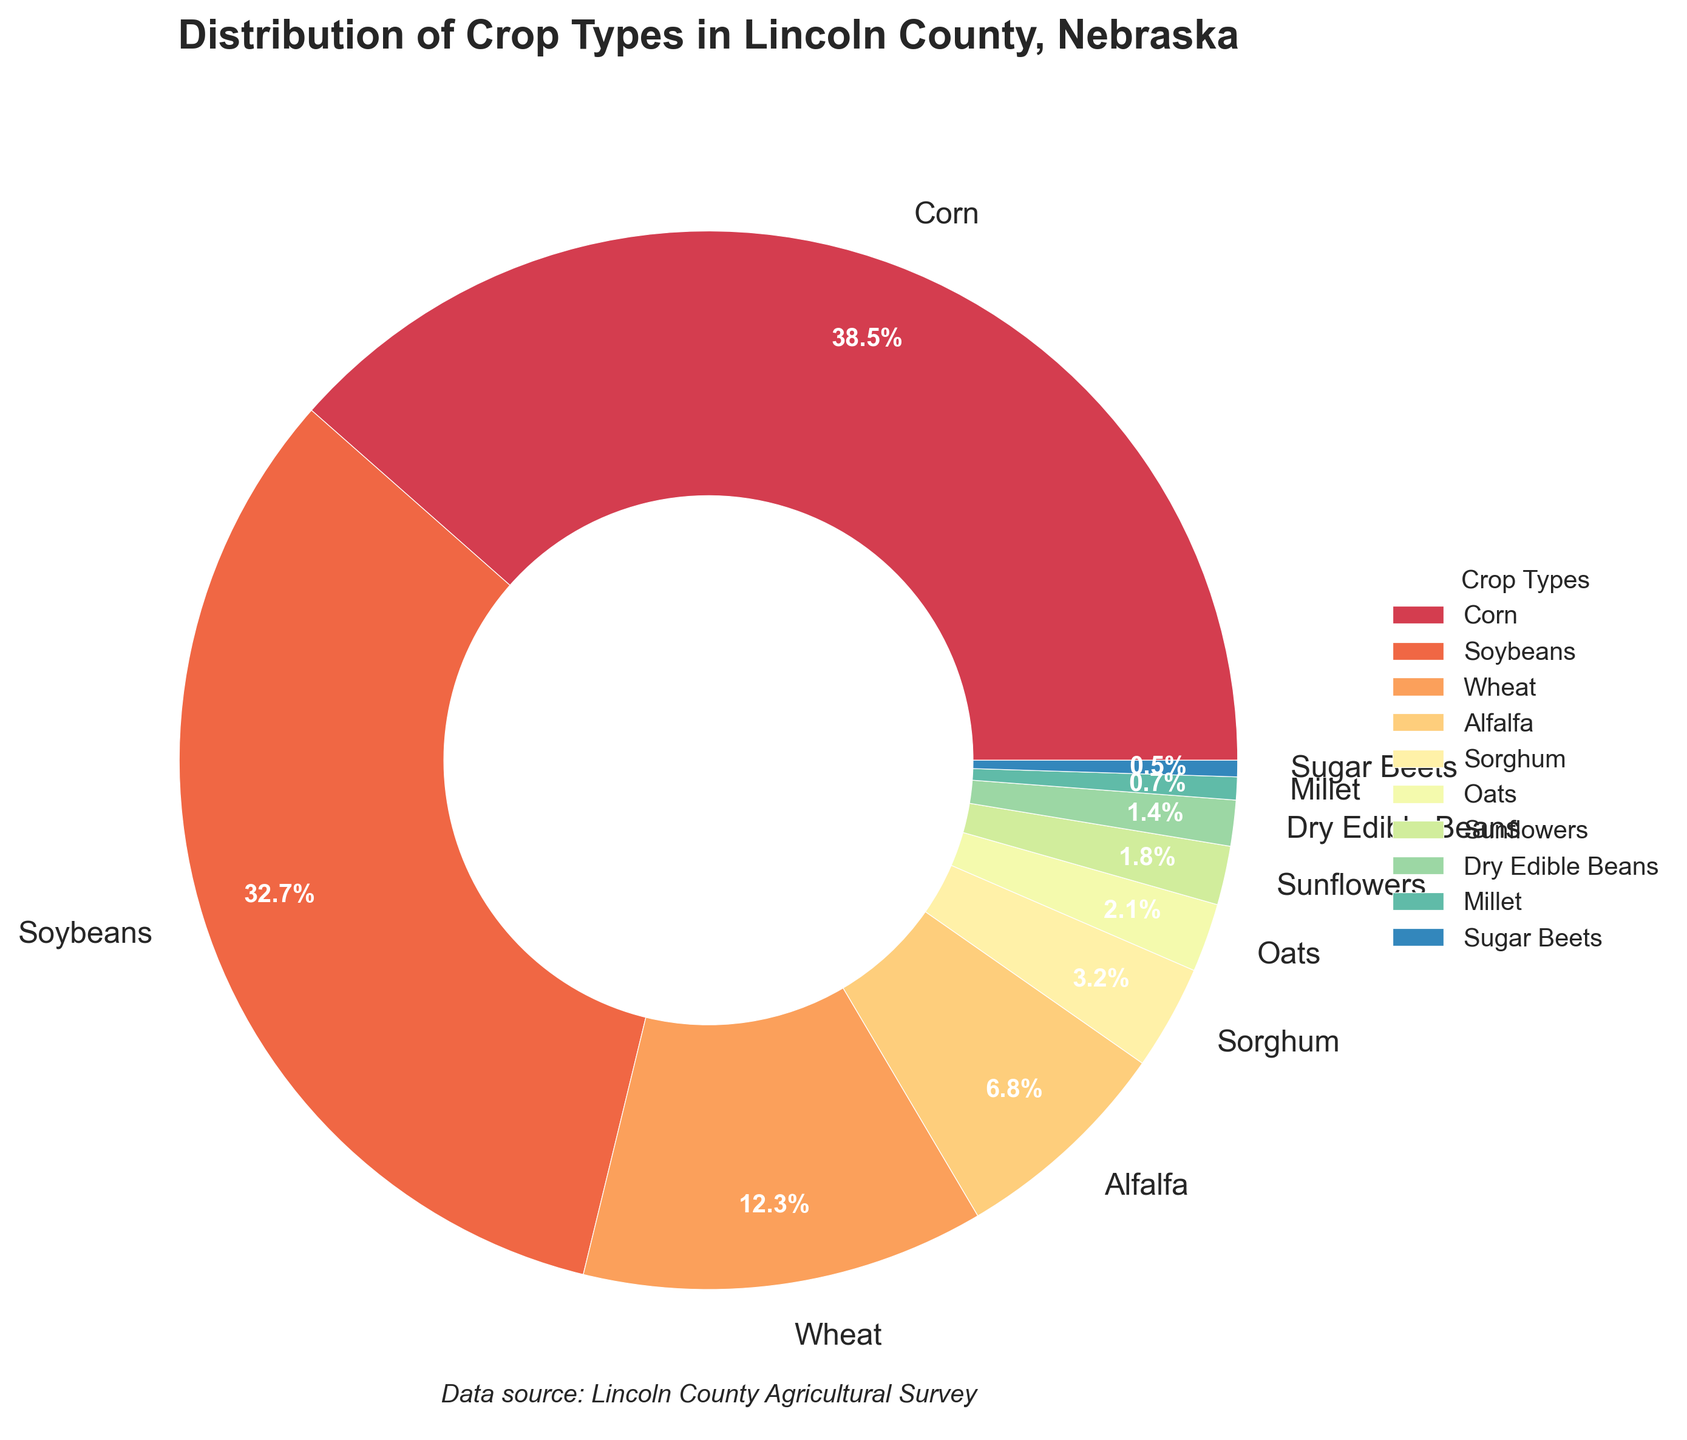Which crop type has the highest percentage? The pie chart shows the distribution of crop types with Corn listed as having 38.5%, the largest segment.
Answer: Corn Which crops together make up more than 70% of the total distribution? By adding the percentages of the largest segments from the chart - Corn (38.5%) + Soybeans (32.7%) = 71.2%, these two crops make up more than 70%.
Answer: Corn and Soybeans Which is the smallest crop type by percentage, and what is its value? The pie chart shows the smallest segment labeled as Sugar Beets with a value of 0.5%.
Answer: Sugar Beets (0.5%) What is the combined percentage of Wheat and Alfalfa? The pie chart shows Wheat at 12.3% and Alfalfa at 6.8%. Adding these together gives 12.3% + 6.8% = 19.1%.
Answer: 19.1% How many crop types have a percentage greater than 10%? The pie chart shows Corn (38.5%), Soybeans (32.7%), and Wheat (12.3%) with values greater than 10%. Counting these, we get 3 crop types.
Answer: 3 Which crop type contributes more, Sorghum or Oats, and by how much? The pie chart shows Sorghum at 3.2% and Oats at 2.1%. The difference is 3.2% - 2.1% = 1.1%.
Answer: Sorghum contributes 1.1% more If you combine the percentages of the smallest three crop types, what is their total percentage? The smallest three crop types from the pie chart are Millet (0.7%), Sugar Beets (0.5%), and Dry Edible Beans (1.4%). Their total is 0.7% + 0.5% + 1.4% = 2.6%.
Answer: 2.6% What percentage of the total does Sunflowers contribute? The pie chart labels Sunflowers with a value of 1.8%, which directly answers the question.
Answer: 1.8% Among Alfalfa, Sorghum, and Oats, which crop has the highest percentage and what is its value? From the pie chart, Alfalfa has 6.8%, Sorghum has 3.2%, and Oats has 2.1%. The highest value among these is Alfalfa with 6.8%.
Answer: Alfalfa (6.8%) 